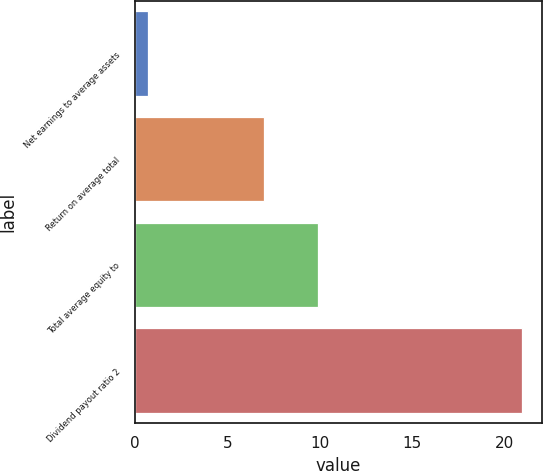Convert chart to OTSL. <chart><loc_0><loc_0><loc_500><loc_500><bar_chart><fcel>Net earnings to average assets<fcel>Return on average total<fcel>Total average equity to<fcel>Dividend payout ratio 2<nl><fcel>0.7<fcel>7<fcel>9.9<fcel>21<nl></chart> 